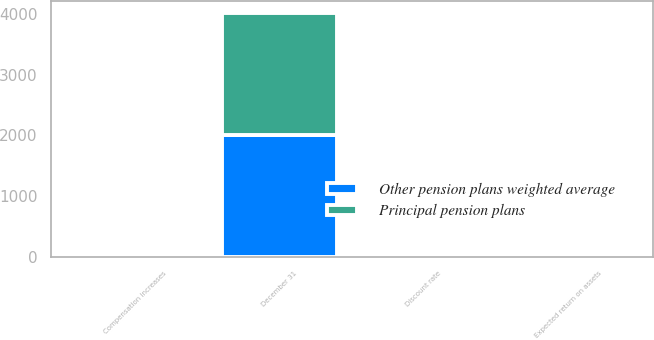Convert chart. <chart><loc_0><loc_0><loc_500><loc_500><stacked_bar_chart><ecel><fcel>December 31<fcel>Discount rate<fcel>Compensation increases<fcel>Expected return on assets<nl><fcel>Principal pension plans<fcel>2008<fcel>6.11<fcel>4.2<fcel>8.5<nl><fcel>Other pension plans weighted average<fcel>2008<fcel>6.03<fcel>4.47<fcel>7.41<nl></chart> 